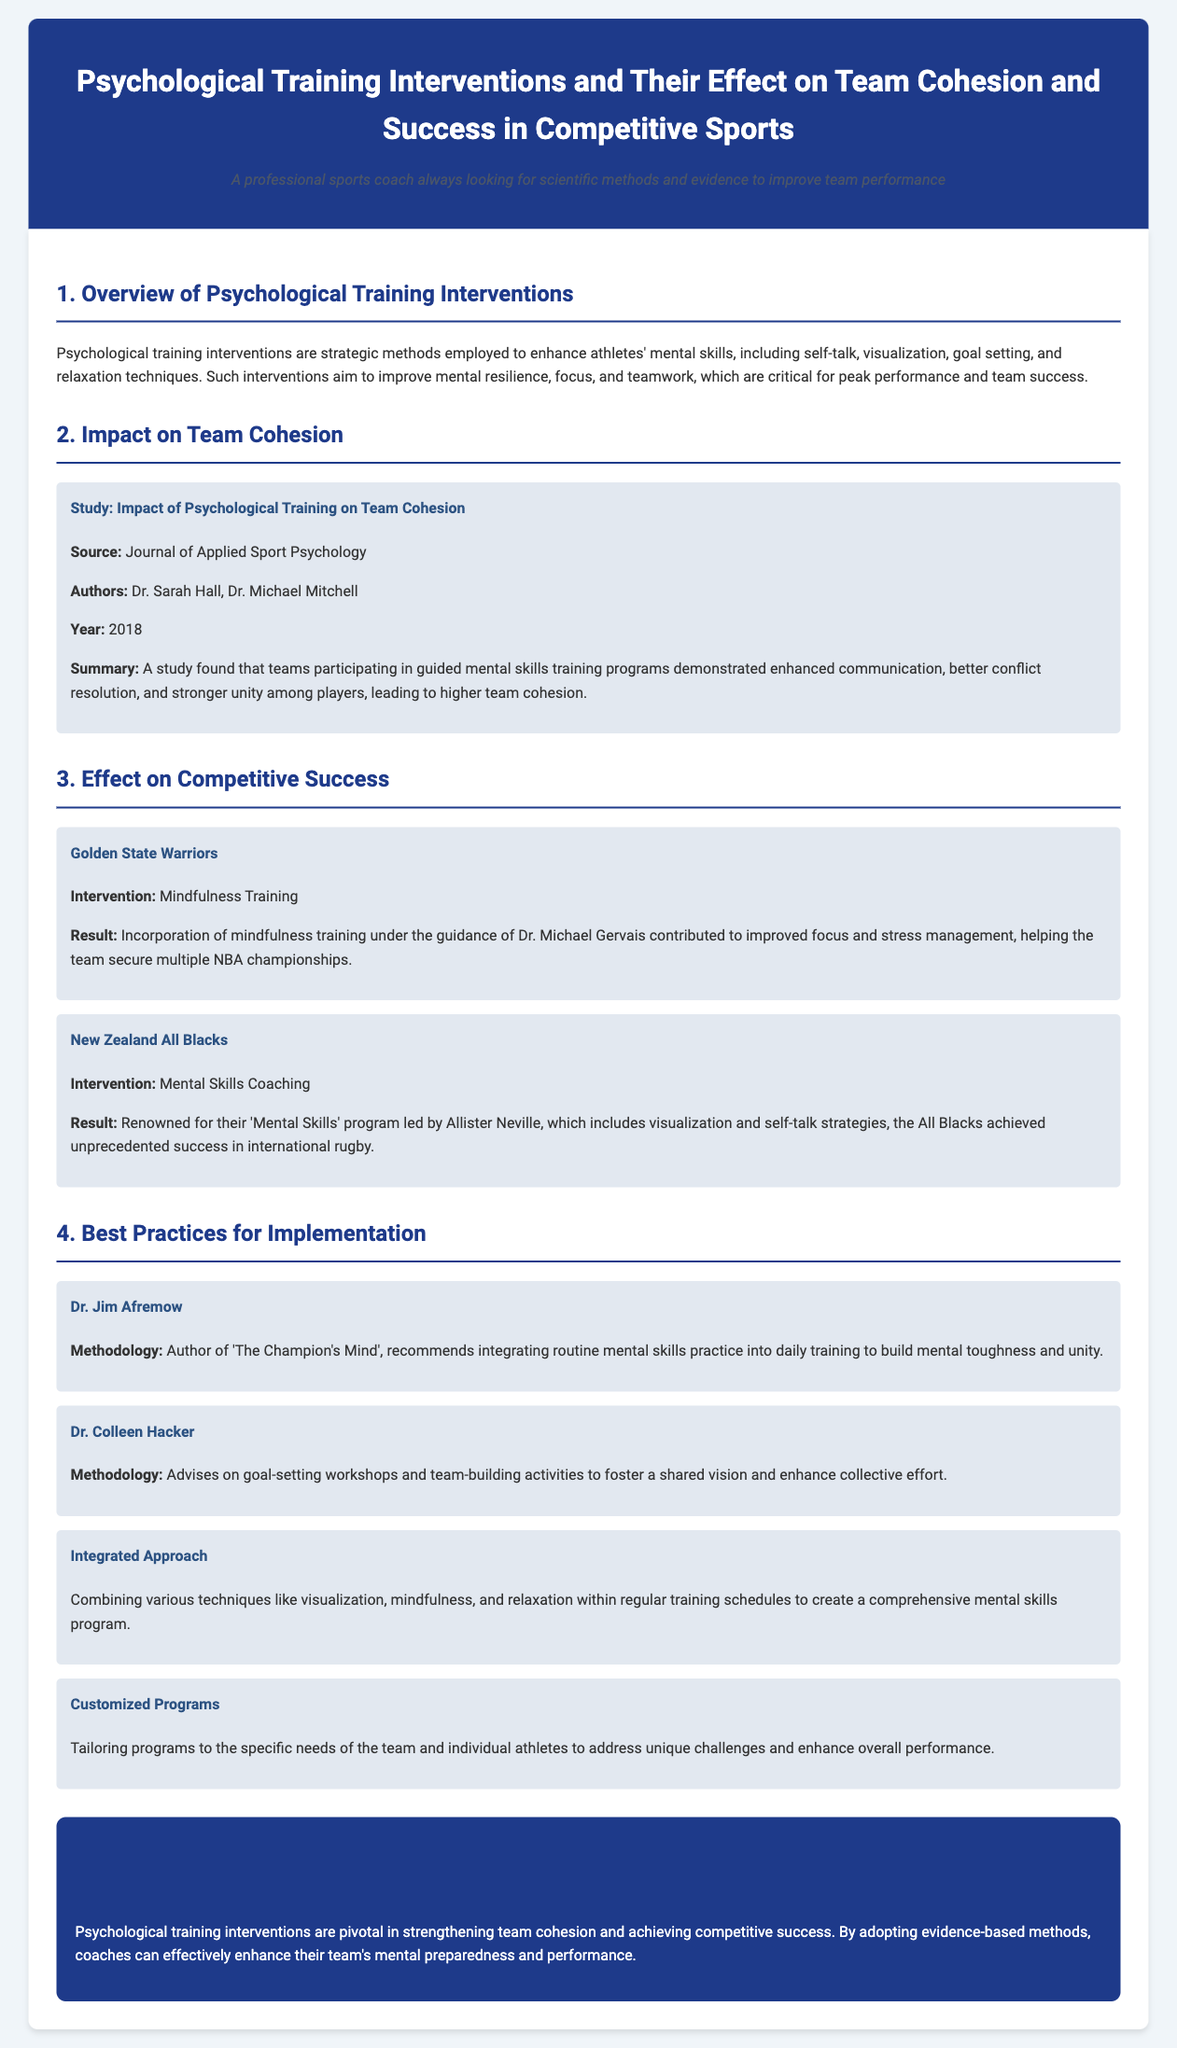what is the focus of psychological training interventions? The focus is to enhance athletes' mental skills, including self-talk, visualization, goal setting, and relaxation techniques.
Answer: mental skills who conducted the study on the impact of psychological training on team cohesion? The study was conducted by Dr. Sarah Hall and Dr. Michael Mitchell.
Answer: Dr. Sarah Hall, Dr. Michael Mitchell what year was the study on team cohesion published? The study was published in 2018.
Answer: 2018 what psychological intervention did the Golden State Warriors implement? The Warriors implemented mindfulness training.
Answer: mindfulness training which renowned team is known for their mental skills program led by Allister Neville? The New Zealand All Blacks are known for their mental skills program.
Answer: New Zealand All Blacks who is the author of 'The Champion's Mind'? The author is Dr. Jim Afremow.
Answer: Dr. Jim Afremow what is a recommended methodology for improving team unity according to Dr. Colleen Hacker? Dr. Colleen Hacker recommends goal-setting workshops and team-building activities.
Answer: goal-setting workshops and team-building activities what is one best practice for implementing psychological training interventions? Combining various techniques like visualization, mindfulness, and relaxation within regular training schedules.
Answer: Integrated Approach what is the overall conclusion regarding psychological training interventions? The conclusion is that they are pivotal in strengthening team cohesion and achieving competitive success.
Answer: pivotal in strengthening team cohesion and achieving competitive success 